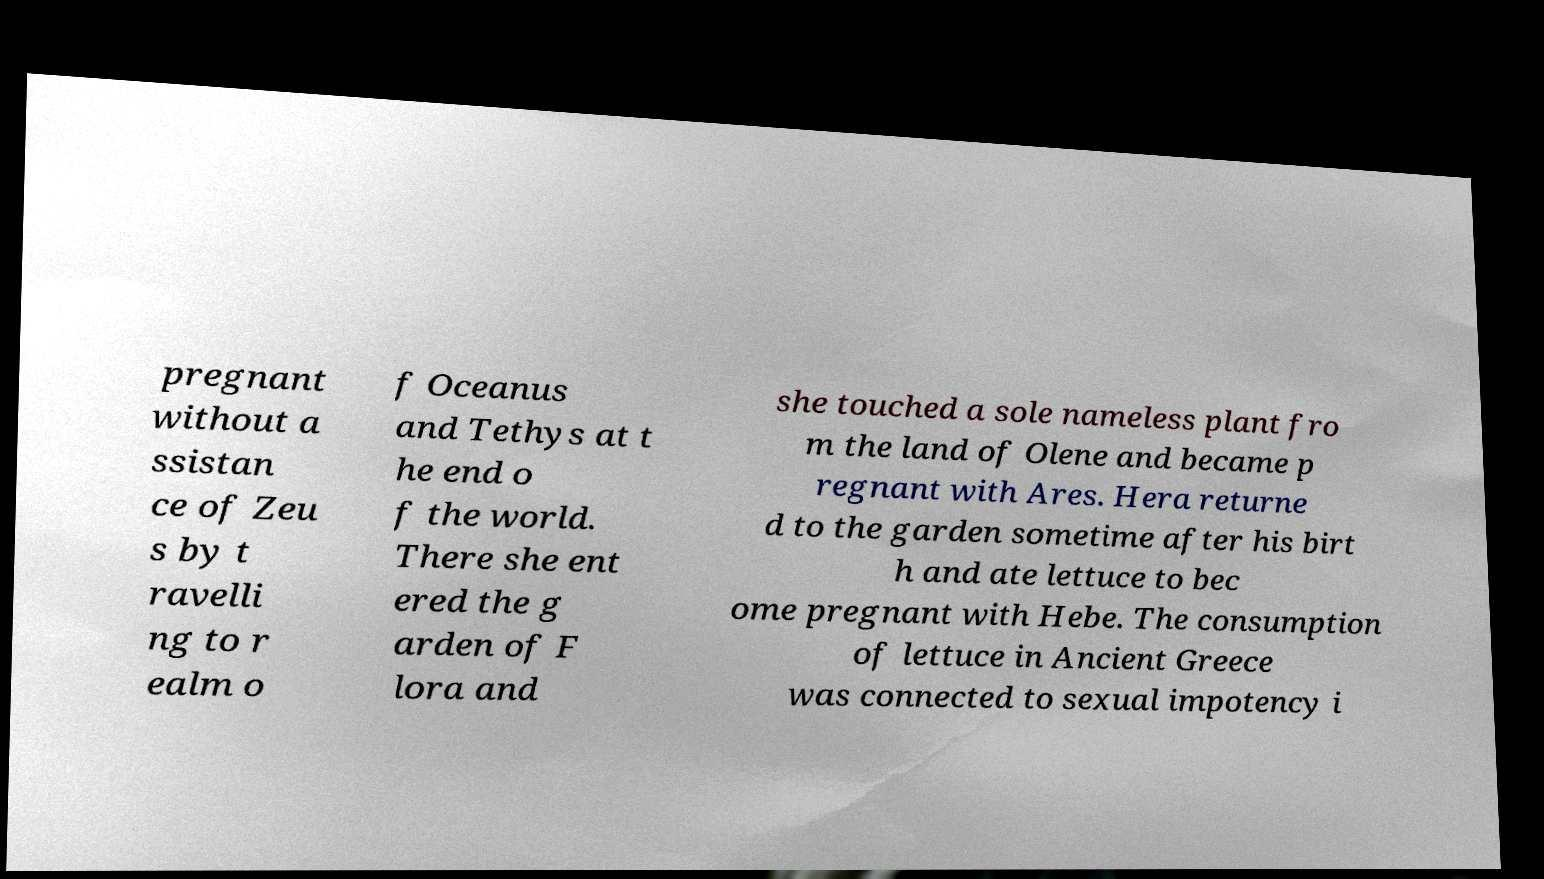Please identify and transcribe the text found in this image. pregnant without a ssistan ce of Zeu s by t ravelli ng to r ealm o f Oceanus and Tethys at t he end o f the world. There she ent ered the g arden of F lora and she touched a sole nameless plant fro m the land of Olene and became p regnant with Ares. Hera returne d to the garden sometime after his birt h and ate lettuce to bec ome pregnant with Hebe. The consumption of lettuce in Ancient Greece was connected to sexual impotency i 